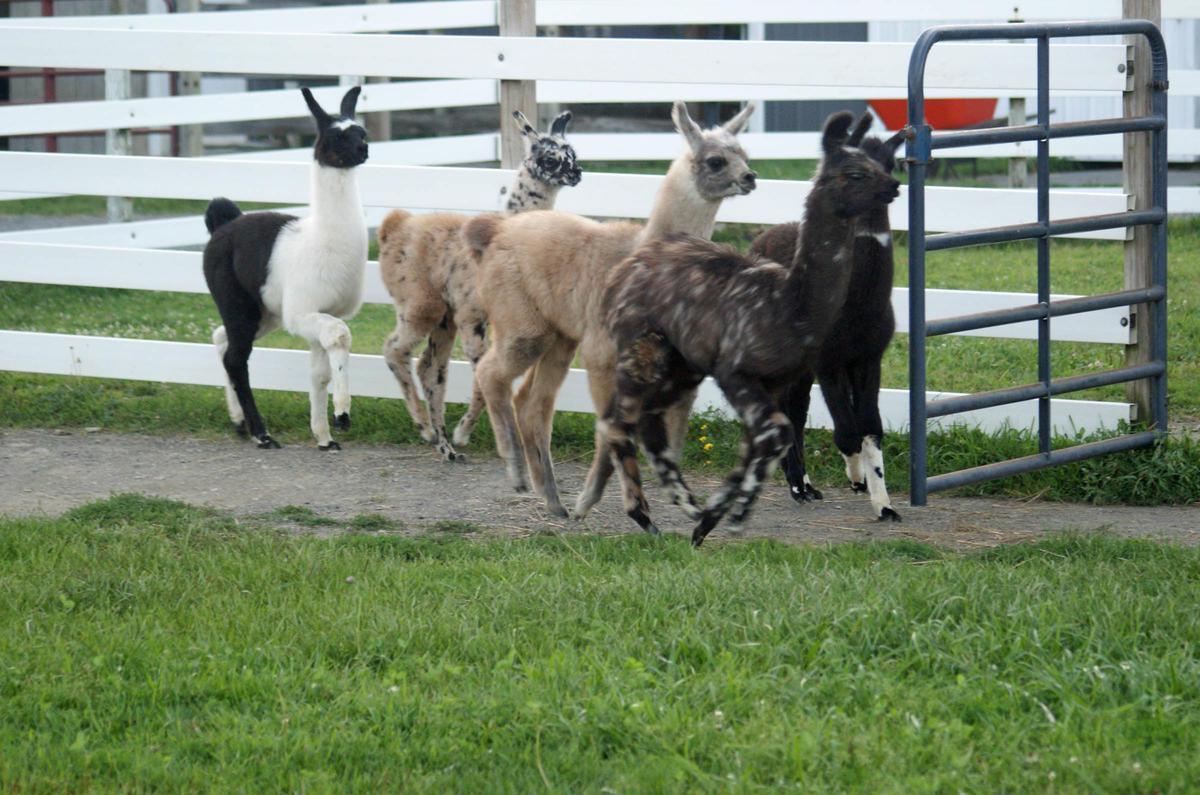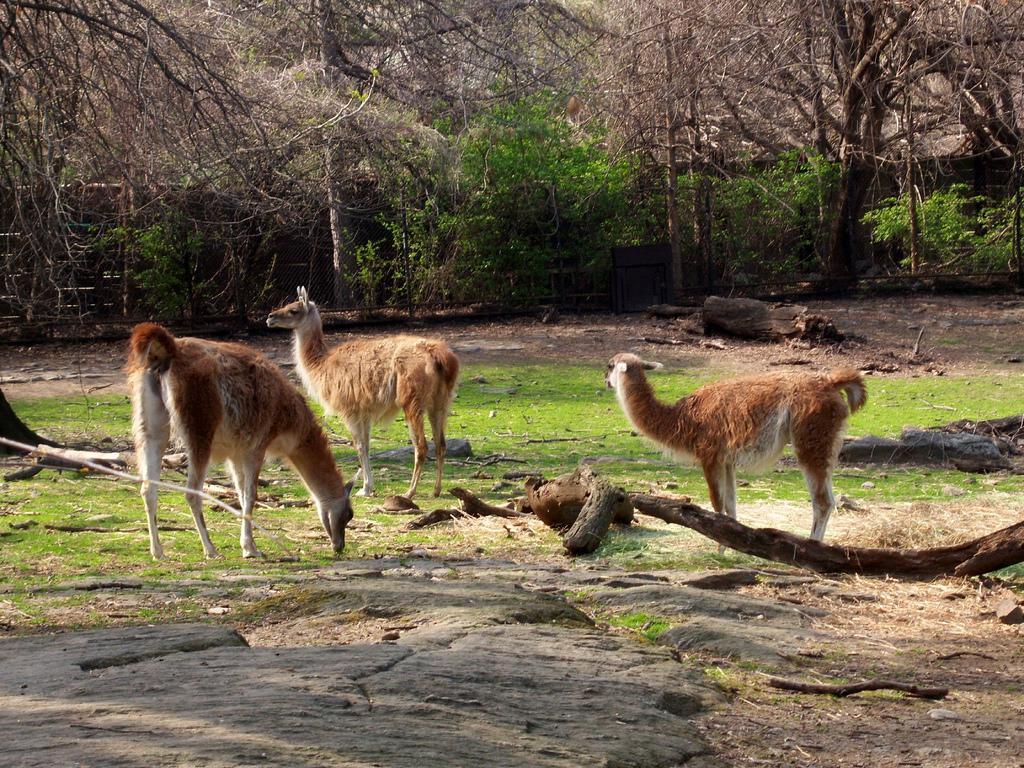The first image is the image on the left, the second image is the image on the right. Analyze the images presented: Is the assertion "Four or fewer llamas are visible." valid? Answer yes or no. No. 